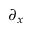Convert formula to latex. <formula><loc_0><loc_0><loc_500><loc_500>\partial _ { x }</formula> 